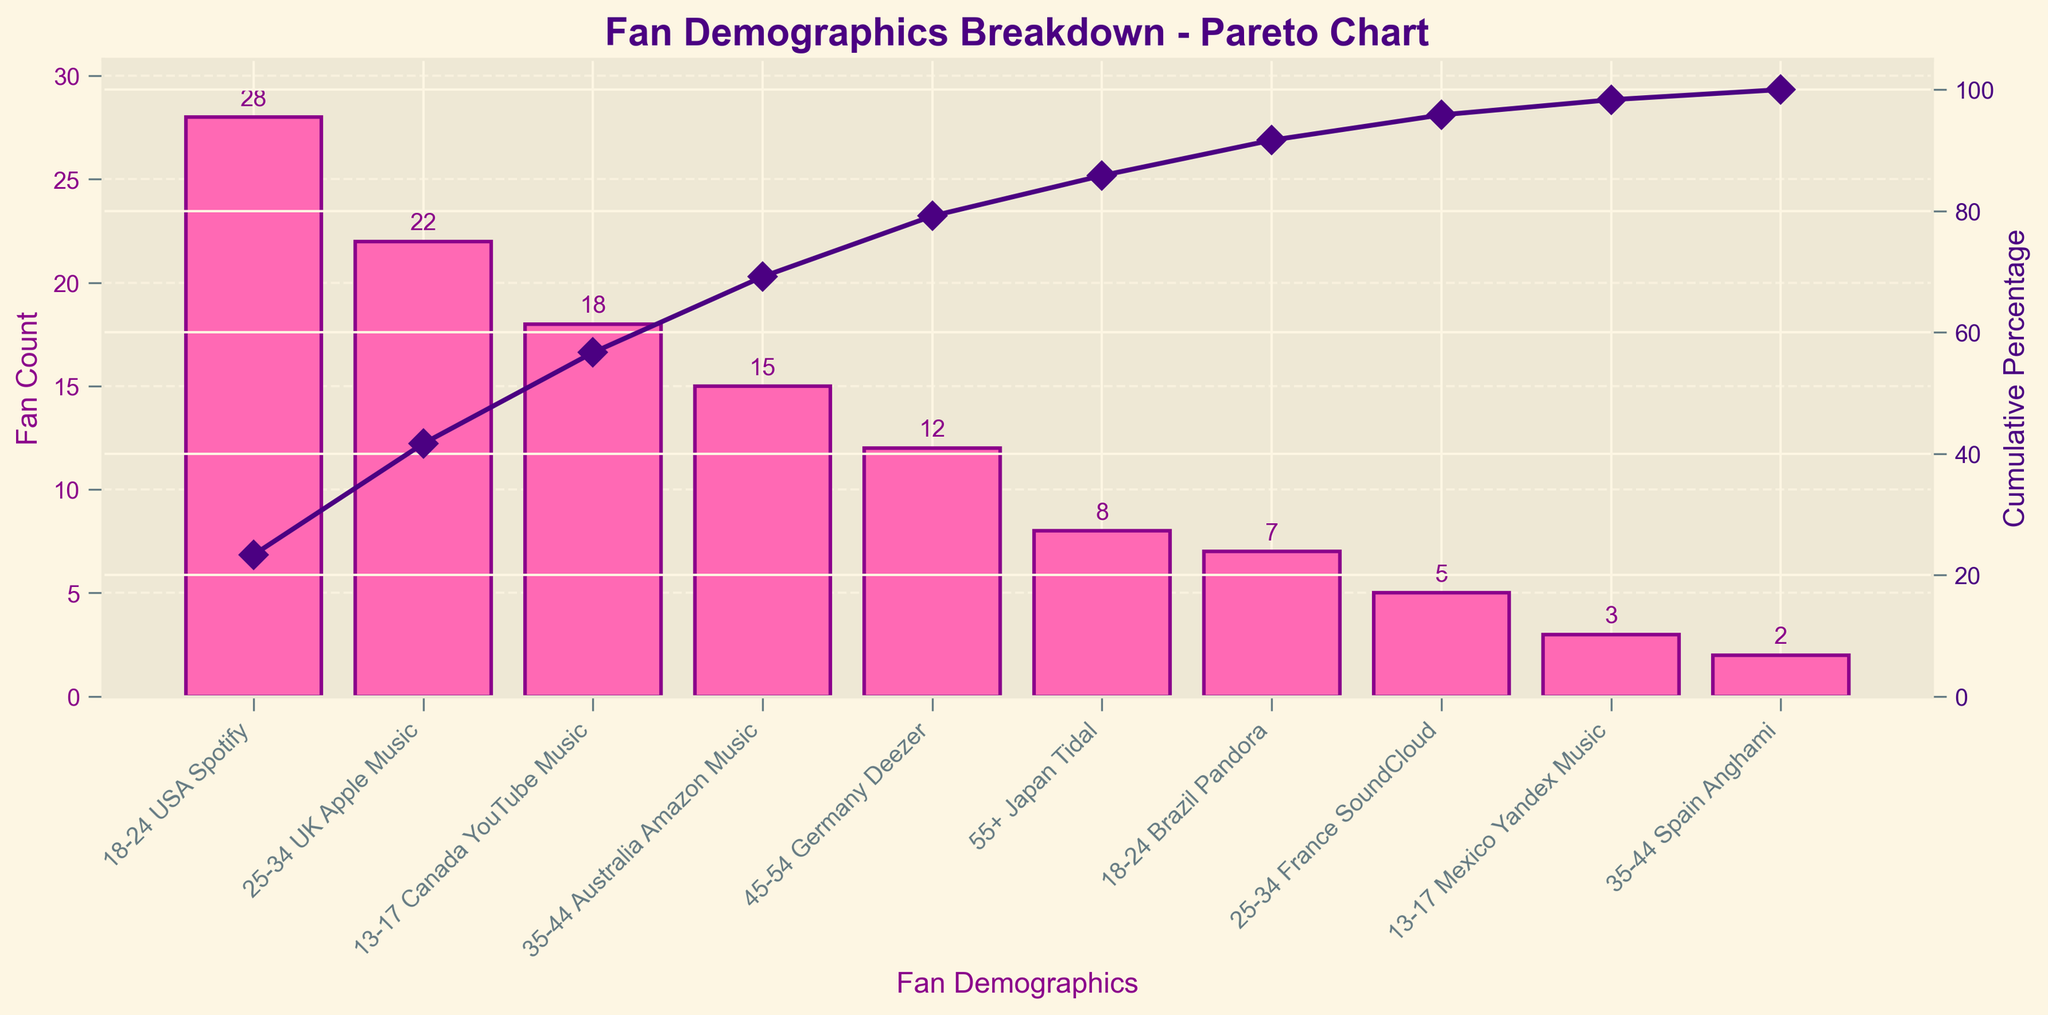What is the title of the chart? The title of the chart is located at the top and provides a summary of what the chart represents.
Answer: Fan Demographics Breakdown - Pareto Chart How many age groups are represented in the chart? The x-axis labels show the different categories which include age groups combined with countries and music streaming platform preferences. We can count these unique combinations.
Answer: 10 Which age group, country, and platform combination has the highest number of fans? The highest bar on the chart indicates the category with the highest number of fans.
Answer: 18-24 USA Spotify What is the cumulative percentage for the "25-34 UK Apple Music" category? To find this, we look at the line graph which indicates the cumulative percentage for each point. Find the marker corresponding to "25-34 UK Apple Music".
Answer: 42% How many fans are represented in the "45-54 Germany Deezer" category, and how does it compare to the "55+ Japan Tidal" category? The heights of the respective bars give us the fan counts. "45-54 Germany Deezer" has 12 fans, and "55+ Japan Tidal" has 8 fans. So, "45-54 Germany Deezer" has 4 more fans than "55+ Japan Tidal".
Answer: 4 more fans What is the total number of fans represented in the chart? The total fan count is the sum of all values in each category. Adding the values (28 + 22 + 18 + 15 + 12 + 8 + 7 + 5 + 3 + 2) gives us the total number of fans.
Answer: 120 Which category has a cumulative percentage just over 60%? Locate the cumulative percentage curve and find the category where the percentage first exceeds 60%.
Answer: 13-17 Canada YouTube Music What is the cumulative percentage after the first three categories? Sum the values of the first three categories: (28 + 22 + 18) = 68. Then calculate the cumulative percentage: (68/120) * 100 ≈ 56.67%.
Answer: 56.67% Comparing "18-24 USA Spotify" and "18-24 Brazil Pandora", by how much does the fan count differ? Identify the heights of these two bars. "18-24 USA Spotify" has 28 fans, and "18-24 Brazil Pandora" has 7 fans. The difference is 28 - 7.
Answer: 21 fans Which age group shows on average the lowest number of fans across the different countries and platforms? Calculate the average fan count for each age group. For example:
- 13-17: (18 + 3)/2 = 10.5
- 18-24: (28 + 7)/2 = 17.5
- And so on.
The group with the lowest average is the one with the lowest calculated value.
Answer: 35-44 